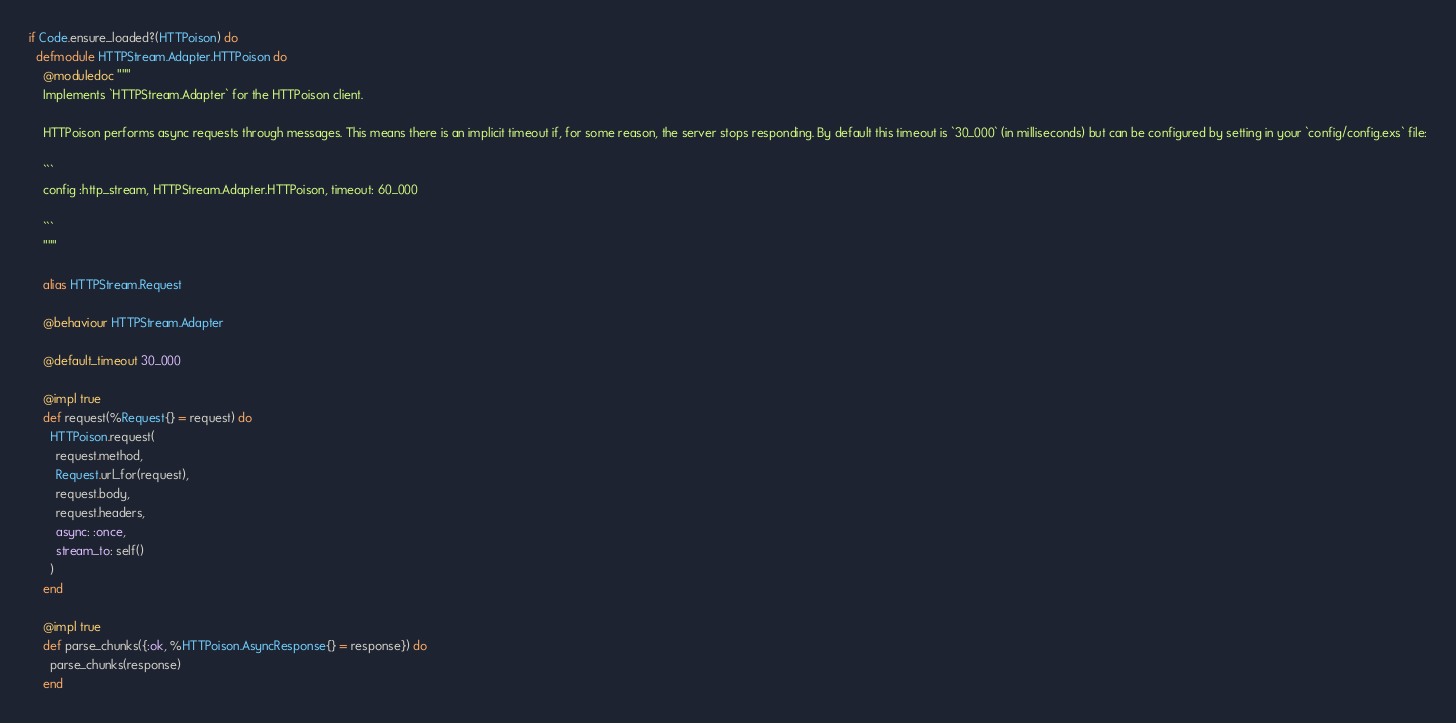Convert code to text. <code><loc_0><loc_0><loc_500><loc_500><_Elixir_>if Code.ensure_loaded?(HTTPoison) do
  defmodule HTTPStream.Adapter.HTTPoison do
    @moduledoc """
    Implements `HTTPStream.Adapter` for the HTTPoison client.

    HTTPoison performs async requests through messages. This means there is an implicit timeout if, for some reason, the server stops responding. By default this timeout is `30_000` (in milliseconds) but can be configured by setting in your `config/config.exs` file:

    ```
    config :http_stream, HTTPStream.Adapter.HTTPoison, timeout: 60_000

    ```
    """

    alias HTTPStream.Request

    @behaviour HTTPStream.Adapter

    @default_timeout 30_000

    @impl true
    def request(%Request{} = request) do
      HTTPoison.request(
        request.method,
        Request.url_for(request),
        request.body,
        request.headers,
        async: :once,
        stream_to: self()
      )
    end

    @impl true
    def parse_chunks({:ok, %HTTPoison.AsyncResponse{} = response}) do
      parse_chunks(response)
    end
</code> 